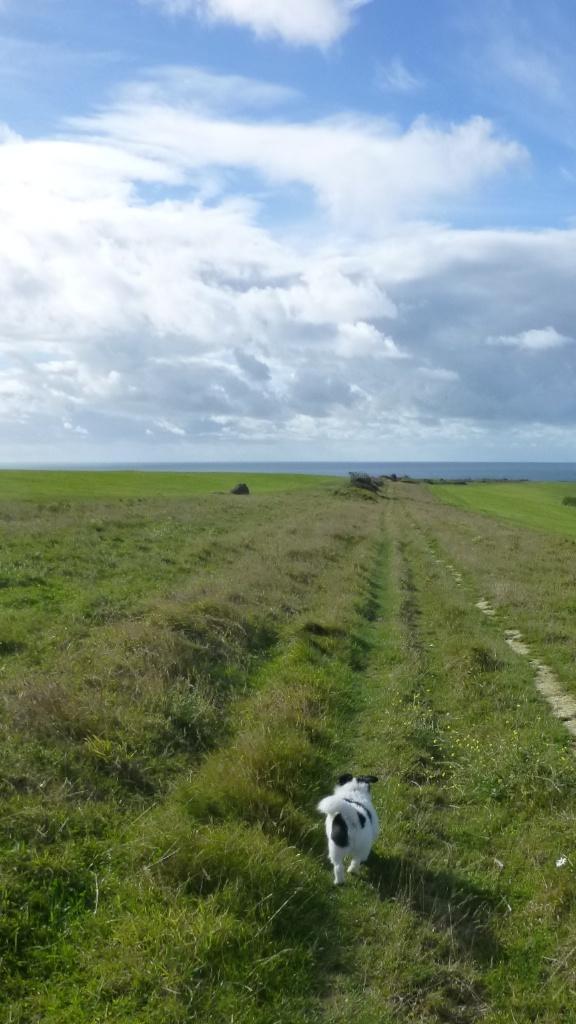Please provide a concise description of this image. In this picture I can see grass on the ground and I can see a dog, it is white and black in color and I can see blue cloudy sky. 